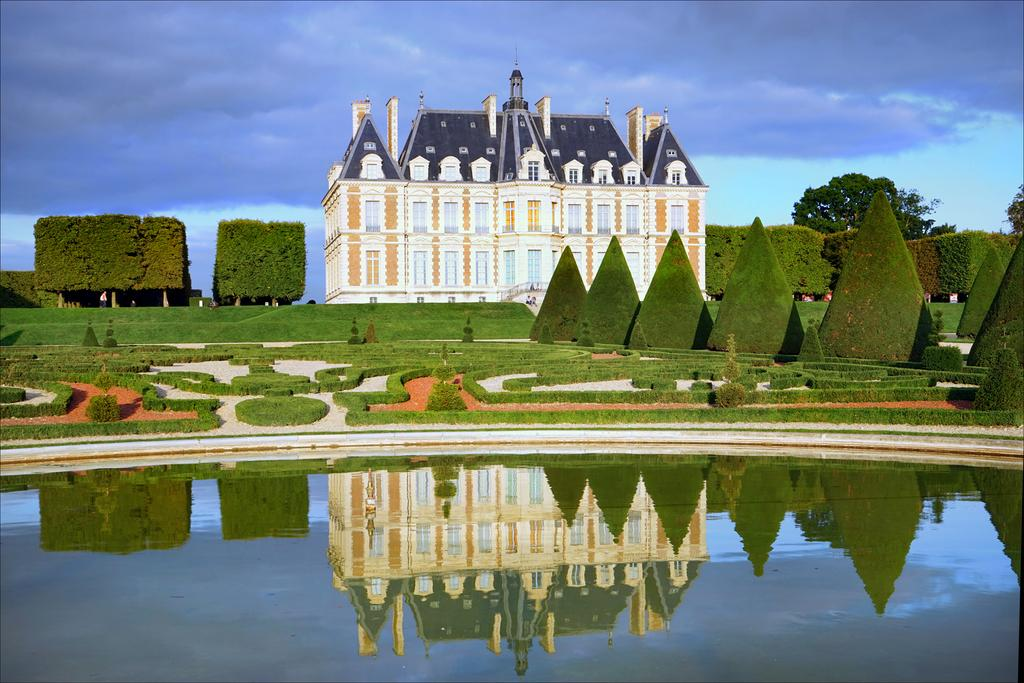What is present in the front of the image? There is water in the front of the image. What can be seen in the background of the image? There are plants, trees, and a castle in the background of the image. What is the condition of the sky in the image? The sky is cloudy in the image. What type of vegetation is on the ground? There is grass on the ground. Can you provide an example of an achiever in the image? There is no person or achiever present in the image; it features water, plants, trees, a castle, a cloudy sky, and grass. Is the river flowing in the image? There is no river mentioned or visible in the image; it features water, plants, trees, a castle, a cloudy sky, and grass. 